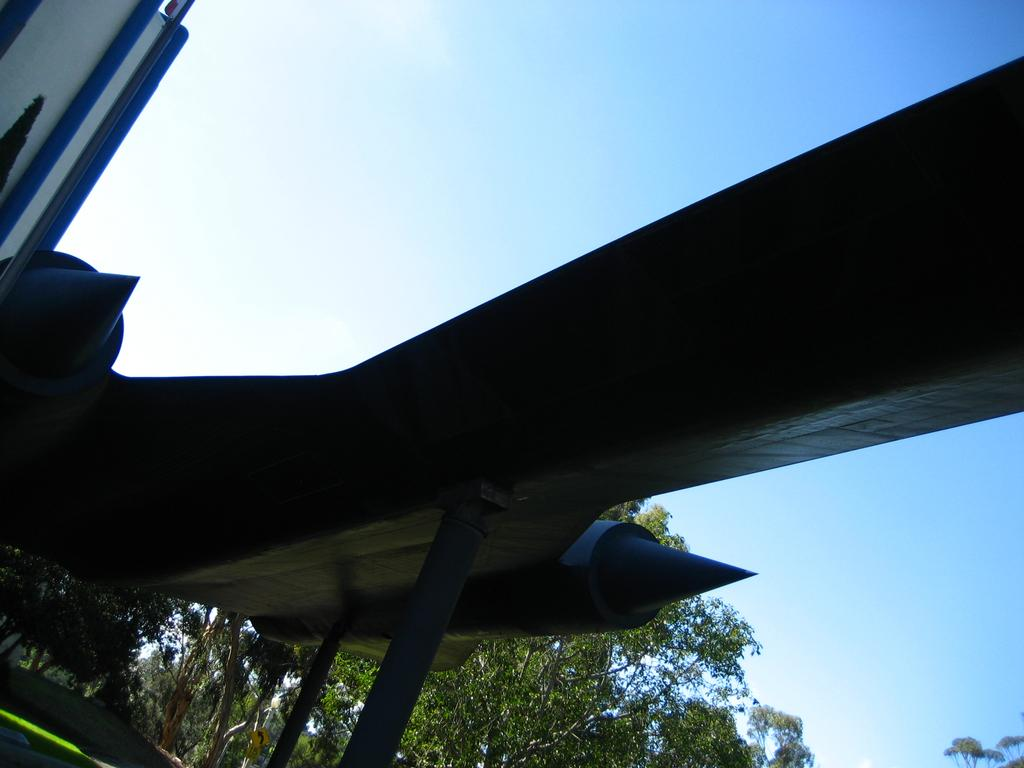What is the main subject in the image? There is a sculpture in the image. What type of natural elements can be seen in the image? There are trees in the image. What type of can is depicted in the sculpture? There is no can present in the image, as it features a sculpture and trees. 